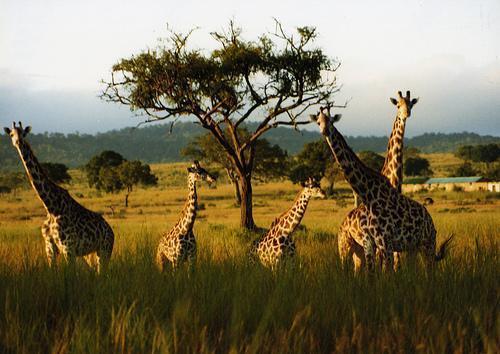How many giraffes are there?
Give a very brief answer. 5. How many giraffes are in the picture?
Give a very brief answer. 5. How many giraffe are pictured?
Give a very brief answer. 5. 